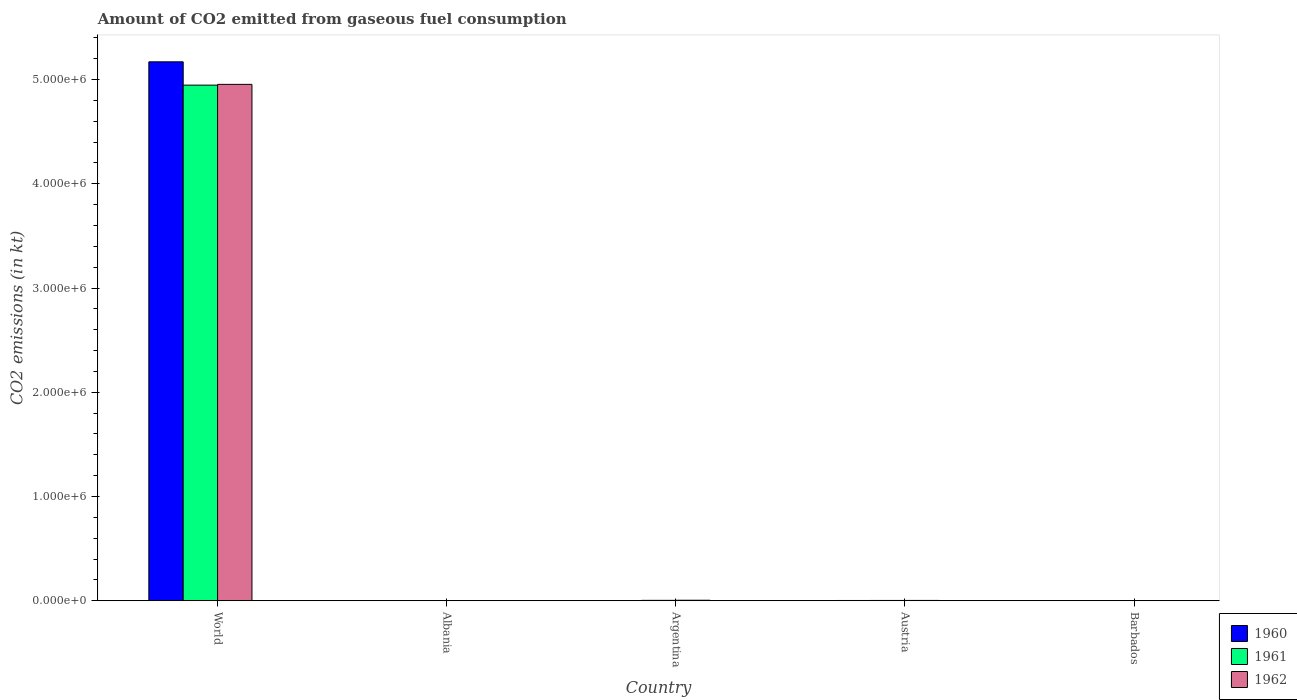How many different coloured bars are there?
Offer a terse response. 3. How many groups of bars are there?
Make the answer very short. 5. Are the number of bars per tick equal to the number of legend labels?
Make the answer very short. Yes. Are the number of bars on each tick of the X-axis equal?
Your answer should be compact. Yes. How many bars are there on the 3rd tick from the left?
Make the answer very short. 3. How many bars are there on the 1st tick from the right?
Offer a terse response. 3. What is the label of the 2nd group of bars from the left?
Make the answer very short. Albania. In how many cases, is the number of bars for a given country not equal to the number of legend labels?
Keep it short and to the point. 0. What is the amount of CO2 emitted in 1962 in Argentina?
Offer a very short reply. 5111.8. Across all countries, what is the maximum amount of CO2 emitted in 1961?
Make the answer very short. 4.95e+06. Across all countries, what is the minimum amount of CO2 emitted in 1962?
Ensure brevity in your answer.  7.33. In which country was the amount of CO2 emitted in 1961 maximum?
Your answer should be compact. World. In which country was the amount of CO2 emitted in 1960 minimum?
Your answer should be compact. Barbados. What is the total amount of CO2 emitted in 1960 in the graph?
Your answer should be compact. 5.18e+06. What is the difference between the amount of CO2 emitted in 1961 in Albania and that in Barbados?
Offer a terse response. 77.01. What is the difference between the amount of CO2 emitted in 1960 in World and the amount of CO2 emitted in 1961 in Albania?
Keep it short and to the point. 5.17e+06. What is the average amount of CO2 emitted in 1961 per country?
Give a very brief answer. 9.91e+05. What is the difference between the amount of CO2 emitted of/in 1960 and amount of CO2 emitted of/in 1961 in Albania?
Offer a very short reply. 0. In how many countries, is the amount of CO2 emitted in 1961 greater than 4200000 kt?
Ensure brevity in your answer.  1. What is the ratio of the amount of CO2 emitted in 1960 in Austria to that in World?
Your answer should be compact. 0. What is the difference between the highest and the second highest amount of CO2 emitted in 1962?
Provide a succinct answer. -4.95e+06. What is the difference between the highest and the lowest amount of CO2 emitted in 1961?
Ensure brevity in your answer.  4.95e+06. In how many countries, is the amount of CO2 emitted in 1962 greater than the average amount of CO2 emitted in 1962 taken over all countries?
Provide a short and direct response. 1. Is the sum of the amount of CO2 emitted in 1962 in Argentina and World greater than the maximum amount of CO2 emitted in 1960 across all countries?
Give a very brief answer. No. What does the 3rd bar from the left in Albania represents?
Give a very brief answer. 1962. How many bars are there?
Give a very brief answer. 15. Are all the bars in the graph horizontal?
Ensure brevity in your answer.  No. How many countries are there in the graph?
Ensure brevity in your answer.  5. Does the graph contain grids?
Offer a very short reply. No. How are the legend labels stacked?
Provide a short and direct response. Vertical. What is the title of the graph?
Offer a very short reply. Amount of CO2 emitted from gaseous fuel consumption. What is the label or title of the Y-axis?
Keep it short and to the point. CO2 emissions (in kt). What is the CO2 emissions (in kt) of 1960 in World?
Give a very brief answer. 5.17e+06. What is the CO2 emissions (in kt) of 1961 in World?
Keep it short and to the point. 4.95e+06. What is the CO2 emissions (in kt) of 1962 in World?
Your answer should be very brief. 4.95e+06. What is the CO2 emissions (in kt) of 1960 in Albania?
Provide a succinct answer. 84.34. What is the CO2 emissions (in kt) of 1961 in Albania?
Give a very brief answer. 84.34. What is the CO2 emissions (in kt) in 1962 in Albania?
Your answer should be compact. 84.34. What is the CO2 emissions (in kt) of 1960 in Argentina?
Make the answer very short. 2365.22. What is the CO2 emissions (in kt) in 1961 in Argentina?
Your answer should be very brief. 4033.7. What is the CO2 emissions (in kt) of 1962 in Argentina?
Offer a terse response. 5111.8. What is the CO2 emissions (in kt) in 1960 in Austria?
Your response must be concise. 2922.6. What is the CO2 emissions (in kt) of 1961 in Austria?
Your response must be concise. 3091.28. What is the CO2 emissions (in kt) in 1962 in Austria?
Your answer should be compact. 3241.63. What is the CO2 emissions (in kt) in 1960 in Barbados?
Offer a terse response. 3.67. What is the CO2 emissions (in kt) of 1961 in Barbados?
Keep it short and to the point. 7.33. What is the CO2 emissions (in kt) in 1962 in Barbados?
Provide a short and direct response. 7.33. Across all countries, what is the maximum CO2 emissions (in kt) in 1960?
Offer a very short reply. 5.17e+06. Across all countries, what is the maximum CO2 emissions (in kt) in 1961?
Ensure brevity in your answer.  4.95e+06. Across all countries, what is the maximum CO2 emissions (in kt) of 1962?
Make the answer very short. 4.95e+06. Across all countries, what is the minimum CO2 emissions (in kt) of 1960?
Give a very brief answer. 3.67. Across all countries, what is the minimum CO2 emissions (in kt) in 1961?
Ensure brevity in your answer.  7.33. Across all countries, what is the minimum CO2 emissions (in kt) in 1962?
Your response must be concise. 7.33. What is the total CO2 emissions (in kt) in 1960 in the graph?
Give a very brief answer. 5.18e+06. What is the total CO2 emissions (in kt) of 1961 in the graph?
Provide a succinct answer. 4.95e+06. What is the total CO2 emissions (in kt) in 1962 in the graph?
Keep it short and to the point. 4.96e+06. What is the difference between the CO2 emissions (in kt) in 1960 in World and that in Albania?
Your response must be concise. 5.17e+06. What is the difference between the CO2 emissions (in kt) in 1961 in World and that in Albania?
Offer a very short reply. 4.95e+06. What is the difference between the CO2 emissions (in kt) in 1962 in World and that in Albania?
Offer a very short reply. 4.95e+06. What is the difference between the CO2 emissions (in kt) in 1960 in World and that in Argentina?
Keep it short and to the point. 5.17e+06. What is the difference between the CO2 emissions (in kt) in 1961 in World and that in Argentina?
Make the answer very short. 4.94e+06. What is the difference between the CO2 emissions (in kt) in 1962 in World and that in Argentina?
Your answer should be very brief. 4.95e+06. What is the difference between the CO2 emissions (in kt) in 1960 in World and that in Austria?
Make the answer very short. 5.17e+06. What is the difference between the CO2 emissions (in kt) in 1961 in World and that in Austria?
Your response must be concise. 4.94e+06. What is the difference between the CO2 emissions (in kt) of 1962 in World and that in Austria?
Your answer should be very brief. 4.95e+06. What is the difference between the CO2 emissions (in kt) of 1960 in World and that in Barbados?
Ensure brevity in your answer.  5.17e+06. What is the difference between the CO2 emissions (in kt) of 1961 in World and that in Barbados?
Your response must be concise. 4.95e+06. What is the difference between the CO2 emissions (in kt) of 1962 in World and that in Barbados?
Your answer should be compact. 4.95e+06. What is the difference between the CO2 emissions (in kt) in 1960 in Albania and that in Argentina?
Your response must be concise. -2280.87. What is the difference between the CO2 emissions (in kt) in 1961 in Albania and that in Argentina?
Give a very brief answer. -3949.36. What is the difference between the CO2 emissions (in kt) of 1962 in Albania and that in Argentina?
Provide a short and direct response. -5027.46. What is the difference between the CO2 emissions (in kt) of 1960 in Albania and that in Austria?
Offer a terse response. -2838.26. What is the difference between the CO2 emissions (in kt) of 1961 in Albania and that in Austria?
Give a very brief answer. -3006.94. What is the difference between the CO2 emissions (in kt) in 1962 in Albania and that in Austria?
Your answer should be very brief. -3157.29. What is the difference between the CO2 emissions (in kt) in 1960 in Albania and that in Barbados?
Offer a terse response. 80.67. What is the difference between the CO2 emissions (in kt) of 1961 in Albania and that in Barbados?
Ensure brevity in your answer.  77.01. What is the difference between the CO2 emissions (in kt) in 1962 in Albania and that in Barbados?
Give a very brief answer. 77.01. What is the difference between the CO2 emissions (in kt) in 1960 in Argentina and that in Austria?
Give a very brief answer. -557.38. What is the difference between the CO2 emissions (in kt) of 1961 in Argentina and that in Austria?
Your answer should be compact. 942.42. What is the difference between the CO2 emissions (in kt) of 1962 in Argentina and that in Austria?
Ensure brevity in your answer.  1870.17. What is the difference between the CO2 emissions (in kt) in 1960 in Argentina and that in Barbados?
Make the answer very short. 2361.55. What is the difference between the CO2 emissions (in kt) of 1961 in Argentina and that in Barbados?
Keep it short and to the point. 4026.37. What is the difference between the CO2 emissions (in kt) of 1962 in Argentina and that in Barbados?
Give a very brief answer. 5104.46. What is the difference between the CO2 emissions (in kt) of 1960 in Austria and that in Barbados?
Make the answer very short. 2918.93. What is the difference between the CO2 emissions (in kt) of 1961 in Austria and that in Barbados?
Your answer should be compact. 3083.95. What is the difference between the CO2 emissions (in kt) in 1962 in Austria and that in Barbados?
Your answer should be very brief. 3234.29. What is the difference between the CO2 emissions (in kt) in 1960 in World and the CO2 emissions (in kt) in 1961 in Albania?
Provide a short and direct response. 5.17e+06. What is the difference between the CO2 emissions (in kt) in 1960 in World and the CO2 emissions (in kt) in 1962 in Albania?
Give a very brief answer. 5.17e+06. What is the difference between the CO2 emissions (in kt) in 1961 in World and the CO2 emissions (in kt) in 1962 in Albania?
Provide a succinct answer. 4.95e+06. What is the difference between the CO2 emissions (in kt) in 1960 in World and the CO2 emissions (in kt) in 1961 in Argentina?
Offer a very short reply. 5.17e+06. What is the difference between the CO2 emissions (in kt) of 1960 in World and the CO2 emissions (in kt) of 1962 in Argentina?
Provide a short and direct response. 5.17e+06. What is the difference between the CO2 emissions (in kt) in 1961 in World and the CO2 emissions (in kt) in 1962 in Argentina?
Your answer should be very brief. 4.94e+06. What is the difference between the CO2 emissions (in kt) of 1960 in World and the CO2 emissions (in kt) of 1961 in Austria?
Make the answer very short. 5.17e+06. What is the difference between the CO2 emissions (in kt) of 1960 in World and the CO2 emissions (in kt) of 1962 in Austria?
Your response must be concise. 5.17e+06. What is the difference between the CO2 emissions (in kt) in 1961 in World and the CO2 emissions (in kt) in 1962 in Austria?
Offer a very short reply. 4.94e+06. What is the difference between the CO2 emissions (in kt) of 1960 in World and the CO2 emissions (in kt) of 1961 in Barbados?
Keep it short and to the point. 5.17e+06. What is the difference between the CO2 emissions (in kt) in 1960 in World and the CO2 emissions (in kt) in 1962 in Barbados?
Offer a terse response. 5.17e+06. What is the difference between the CO2 emissions (in kt) of 1961 in World and the CO2 emissions (in kt) of 1962 in Barbados?
Give a very brief answer. 4.95e+06. What is the difference between the CO2 emissions (in kt) of 1960 in Albania and the CO2 emissions (in kt) of 1961 in Argentina?
Make the answer very short. -3949.36. What is the difference between the CO2 emissions (in kt) in 1960 in Albania and the CO2 emissions (in kt) in 1962 in Argentina?
Offer a terse response. -5027.46. What is the difference between the CO2 emissions (in kt) of 1961 in Albania and the CO2 emissions (in kt) of 1962 in Argentina?
Offer a terse response. -5027.46. What is the difference between the CO2 emissions (in kt) in 1960 in Albania and the CO2 emissions (in kt) in 1961 in Austria?
Offer a very short reply. -3006.94. What is the difference between the CO2 emissions (in kt) in 1960 in Albania and the CO2 emissions (in kt) in 1962 in Austria?
Keep it short and to the point. -3157.29. What is the difference between the CO2 emissions (in kt) of 1961 in Albania and the CO2 emissions (in kt) of 1962 in Austria?
Offer a terse response. -3157.29. What is the difference between the CO2 emissions (in kt) in 1960 in Albania and the CO2 emissions (in kt) in 1961 in Barbados?
Give a very brief answer. 77.01. What is the difference between the CO2 emissions (in kt) in 1960 in Albania and the CO2 emissions (in kt) in 1962 in Barbados?
Keep it short and to the point. 77.01. What is the difference between the CO2 emissions (in kt) in 1961 in Albania and the CO2 emissions (in kt) in 1962 in Barbados?
Your response must be concise. 77.01. What is the difference between the CO2 emissions (in kt) in 1960 in Argentina and the CO2 emissions (in kt) in 1961 in Austria?
Provide a succinct answer. -726.07. What is the difference between the CO2 emissions (in kt) in 1960 in Argentina and the CO2 emissions (in kt) in 1962 in Austria?
Offer a terse response. -876.41. What is the difference between the CO2 emissions (in kt) in 1961 in Argentina and the CO2 emissions (in kt) in 1962 in Austria?
Your response must be concise. 792.07. What is the difference between the CO2 emissions (in kt) in 1960 in Argentina and the CO2 emissions (in kt) in 1961 in Barbados?
Your response must be concise. 2357.88. What is the difference between the CO2 emissions (in kt) of 1960 in Argentina and the CO2 emissions (in kt) of 1962 in Barbados?
Provide a succinct answer. 2357.88. What is the difference between the CO2 emissions (in kt) in 1961 in Argentina and the CO2 emissions (in kt) in 1962 in Barbados?
Provide a succinct answer. 4026.37. What is the difference between the CO2 emissions (in kt) of 1960 in Austria and the CO2 emissions (in kt) of 1961 in Barbados?
Offer a terse response. 2915.26. What is the difference between the CO2 emissions (in kt) in 1960 in Austria and the CO2 emissions (in kt) in 1962 in Barbados?
Your answer should be compact. 2915.26. What is the difference between the CO2 emissions (in kt) of 1961 in Austria and the CO2 emissions (in kt) of 1962 in Barbados?
Offer a very short reply. 3083.95. What is the average CO2 emissions (in kt) in 1960 per country?
Your response must be concise. 1.04e+06. What is the average CO2 emissions (in kt) in 1961 per country?
Offer a very short reply. 9.91e+05. What is the average CO2 emissions (in kt) in 1962 per country?
Offer a very short reply. 9.93e+05. What is the difference between the CO2 emissions (in kt) in 1960 and CO2 emissions (in kt) in 1961 in World?
Give a very brief answer. 2.24e+05. What is the difference between the CO2 emissions (in kt) of 1960 and CO2 emissions (in kt) of 1962 in World?
Provide a succinct answer. 2.16e+05. What is the difference between the CO2 emissions (in kt) in 1961 and CO2 emissions (in kt) in 1962 in World?
Offer a very short reply. -7334. What is the difference between the CO2 emissions (in kt) in 1961 and CO2 emissions (in kt) in 1962 in Albania?
Provide a succinct answer. 0. What is the difference between the CO2 emissions (in kt) of 1960 and CO2 emissions (in kt) of 1961 in Argentina?
Offer a very short reply. -1668.48. What is the difference between the CO2 emissions (in kt) of 1960 and CO2 emissions (in kt) of 1962 in Argentina?
Offer a very short reply. -2746.58. What is the difference between the CO2 emissions (in kt) of 1961 and CO2 emissions (in kt) of 1962 in Argentina?
Make the answer very short. -1078.1. What is the difference between the CO2 emissions (in kt) of 1960 and CO2 emissions (in kt) of 1961 in Austria?
Make the answer very short. -168.68. What is the difference between the CO2 emissions (in kt) of 1960 and CO2 emissions (in kt) of 1962 in Austria?
Provide a succinct answer. -319.03. What is the difference between the CO2 emissions (in kt) in 1961 and CO2 emissions (in kt) in 1962 in Austria?
Offer a very short reply. -150.35. What is the difference between the CO2 emissions (in kt) of 1960 and CO2 emissions (in kt) of 1961 in Barbados?
Ensure brevity in your answer.  -3.67. What is the difference between the CO2 emissions (in kt) in 1960 and CO2 emissions (in kt) in 1962 in Barbados?
Offer a very short reply. -3.67. What is the ratio of the CO2 emissions (in kt) in 1960 in World to that in Albania?
Ensure brevity in your answer.  6.13e+04. What is the ratio of the CO2 emissions (in kt) in 1961 in World to that in Albania?
Your answer should be very brief. 5.87e+04. What is the ratio of the CO2 emissions (in kt) in 1962 in World to that in Albania?
Give a very brief answer. 5.87e+04. What is the ratio of the CO2 emissions (in kt) of 1960 in World to that in Argentina?
Keep it short and to the point. 2186.05. What is the ratio of the CO2 emissions (in kt) in 1961 in World to that in Argentina?
Provide a short and direct response. 1226.36. What is the ratio of the CO2 emissions (in kt) in 1962 in World to that in Argentina?
Offer a very short reply. 969.15. What is the ratio of the CO2 emissions (in kt) in 1960 in World to that in Austria?
Ensure brevity in your answer.  1769.13. What is the ratio of the CO2 emissions (in kt) in 1961 in World to that in Austria?
Your answer should be compact. 1600.24. What is the ratio of the CO2 emissions (in kt) of 1962 in World to that in Austria?
Offer a very short reply. 1528.28. What is the ratio of the CO2 emissions (in kt) in 1960 in World to that in Barbados?
Ensure brevity in your answer.  1.41e+06. What is the ratio of the CO2 emissions (in kt) of 1961 in World to that in Barbados?
Make the answer very short. 6.74e+05. What is the ratio of the CO2 emissions (in kt) in 1962 in World to that in Barbados?
Your answer should be very brief. 6.76e+05. What is the ratio of the CO2 emissions (in kt) of 1960 in Albania to that in Argentina?
Keep it short and to the point. 0.04. What is the ratio of the CO2 emissions (in kt) of 1961 in Albania to that in Argentina?
Your response must be concise. 0.02. What is the ratio of the CO2 emissions (in kt) of 1962 in Albania to that in Argentina?
Your answer should be very brief. 0.02. What is the ratio of the CO2 emissions (in kt) in 1960 in Albania to that in Austria?
Make the answer very short. 0.03. What is the ratio of the CO2 emissions (in kt) of 1961 in Albania to that in Austria?
Keep it short and to the point. 0.03. What is the ratio of the CO2 emissions (in kt) of 1962 in Albania to that in Austria?
Ensure brevity in your answer.  0.03. What is the ratio of the CO2 emissions (in kt) of 1960 in Albania to that in Barbados?
Provide a succinct answer. 23. What is the ratio of the CO2 emissions (in kt) of 1960 in Argentina to that in Austria?
Ensure brevity in your answer.  0.81. What is the ratio of the CO2 emissions (in kt) of 1961 in Argentina to that in Austria?
Offer a terse response. 1.3. What is the ratio of the CO2 emissions (in kt) of 1962 in Argentina to that in Austria?
Provide a short and direct response. 1.58. What is the ratio of the CO2 emissions (in kt) in 1960 in Argentina to that in Barbados?
Give a very brief answer. 645. What is the ratio of the CO2 emissions (in kt) in 1961 in Argentina to that in Barbados?
Make the answer very short. 550. What is the ratio of the CO2 emissions (in kt) in 1962 in Argentina to that in Barbados?
Ensure brevity in your answer.  697. What is the ratio of the CO2 emissions (in kt) of 1960 in Austria to that in Barbados?
Make the answer very short. 797. What is the ratio of the CO2 emissions (in kt) of 1961 in Austria to that in Barbados?
Offer a very short reply. 421.5. What is the ratio of the CO2 emissions (in kt) in 1962 in Austria to that in Barbados?
Your answer should be compact. 442. What is the difference between the highest and the second highest CO2 emissions (in kt) in 1960?
Offer a very short reply. 5.17e+06. What is the difference between the highest and the second highest CO2 emissions (in kt) of 1961?
Offer a very short reply. 4.94e+06. What is the difference between the highest and the second highest CO2 emissions (in kt) of 1962?
Your answer should be compact. 4.95e+06. What is the difference between the highest and the lowest CO2 emissions (in kt) in 1960?
Keep it short and to the point. 5.17e+06. What is the difference between the highest and the lowest CO2 emissions (in kt) of 1961?
Provide a short and direct response. 4.95e+06. What is the difference between the highest and the lowest CO2 emissions (in kt) of 1962?
Provide a short and direct response. 4.95e+06. 